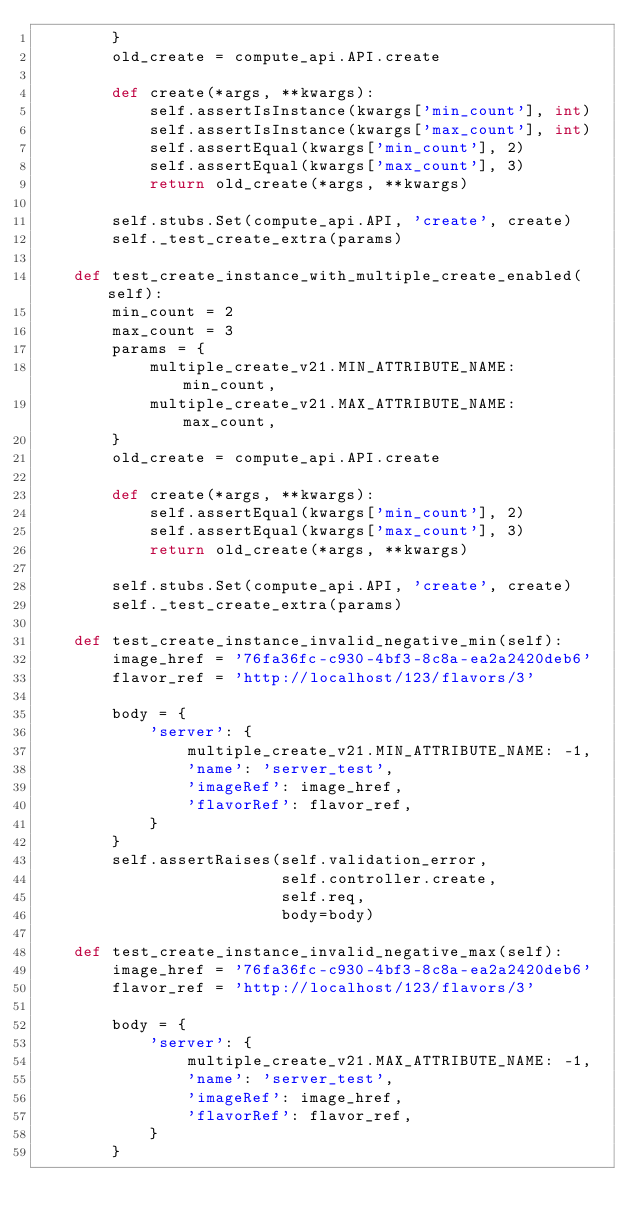Convert code to text. <code><loc_0><loc_0><loc_500><loc_500><_Python_>        }
        old_create = compute_api.API.create

        def create(*args, **kwargs):
            self.assertIsInstance(kwargs['min_count'], int)
            self.assertIsInstance(kwargs['max_count'], int)
            self.assertEqual(kwargs['min_count'], 2)
            self.assertEqual(kwargs['max_count'], 3)
            return old_create(*args, **kwargs)

        self.stubs.Set(compute_api.API, 'create', create)
        self._test_create_extra(params)

    def test_create_instance_with_multiple_create_enabled(self):
        min_count = 2
        max_count = 3
        params = {
            multiple_create_v21.MIN_ATTRIBUTE_NAME: min_count,
            multiple_create_v21.MAX_ATTRIBUTE_NAME: max_count,
        }
        old_create = compute_api.API.create

        def create(*args, **kwargs):
            self.assertEqual(kwargs['min_count'], 2)
            self.assertEqual(kwargs['max_count'], 3)
            return old_create(*args, **kwargs)

        self.stubs.Set(compute_api.API, 'create', create)
        self._test_create_extra(params)

    def test_create_instance_invalid_negative_min(self):
        image_href = '76fa36fc-c930-4bf3-8c8a-ea2a2420deb6'
        flavor_ref = 'http://localhost/123/flavors/3'

        body = {
            'server': {
                multiple_create_v21.MIN_ATTRIBUTE_NAME: -1,
                'name': 'server_test',
                'imageRef': image_href,
                'flavorRef': flavor_ref,
            }
        }
        self.assertRaises(self.validation_error,
                          self.controller.create,
                          self.req,
                          body=body)

    def test_create_instance_invalid_negative_max(self):
        image_href = '76fa36fc-c930-4bf3-8c8a-ea2a2420deb6'
        flavor_ref = 'http://localhost/123/flavors/3'

        body = {
            'server': {
                multiple_create_v21.MAX_ATTRIBUTE_NAME: -1,
                'name': 'server_test',
                'imageRef': image_href,
                'flavorRef': flavor_ref,
            }
        }</code> 